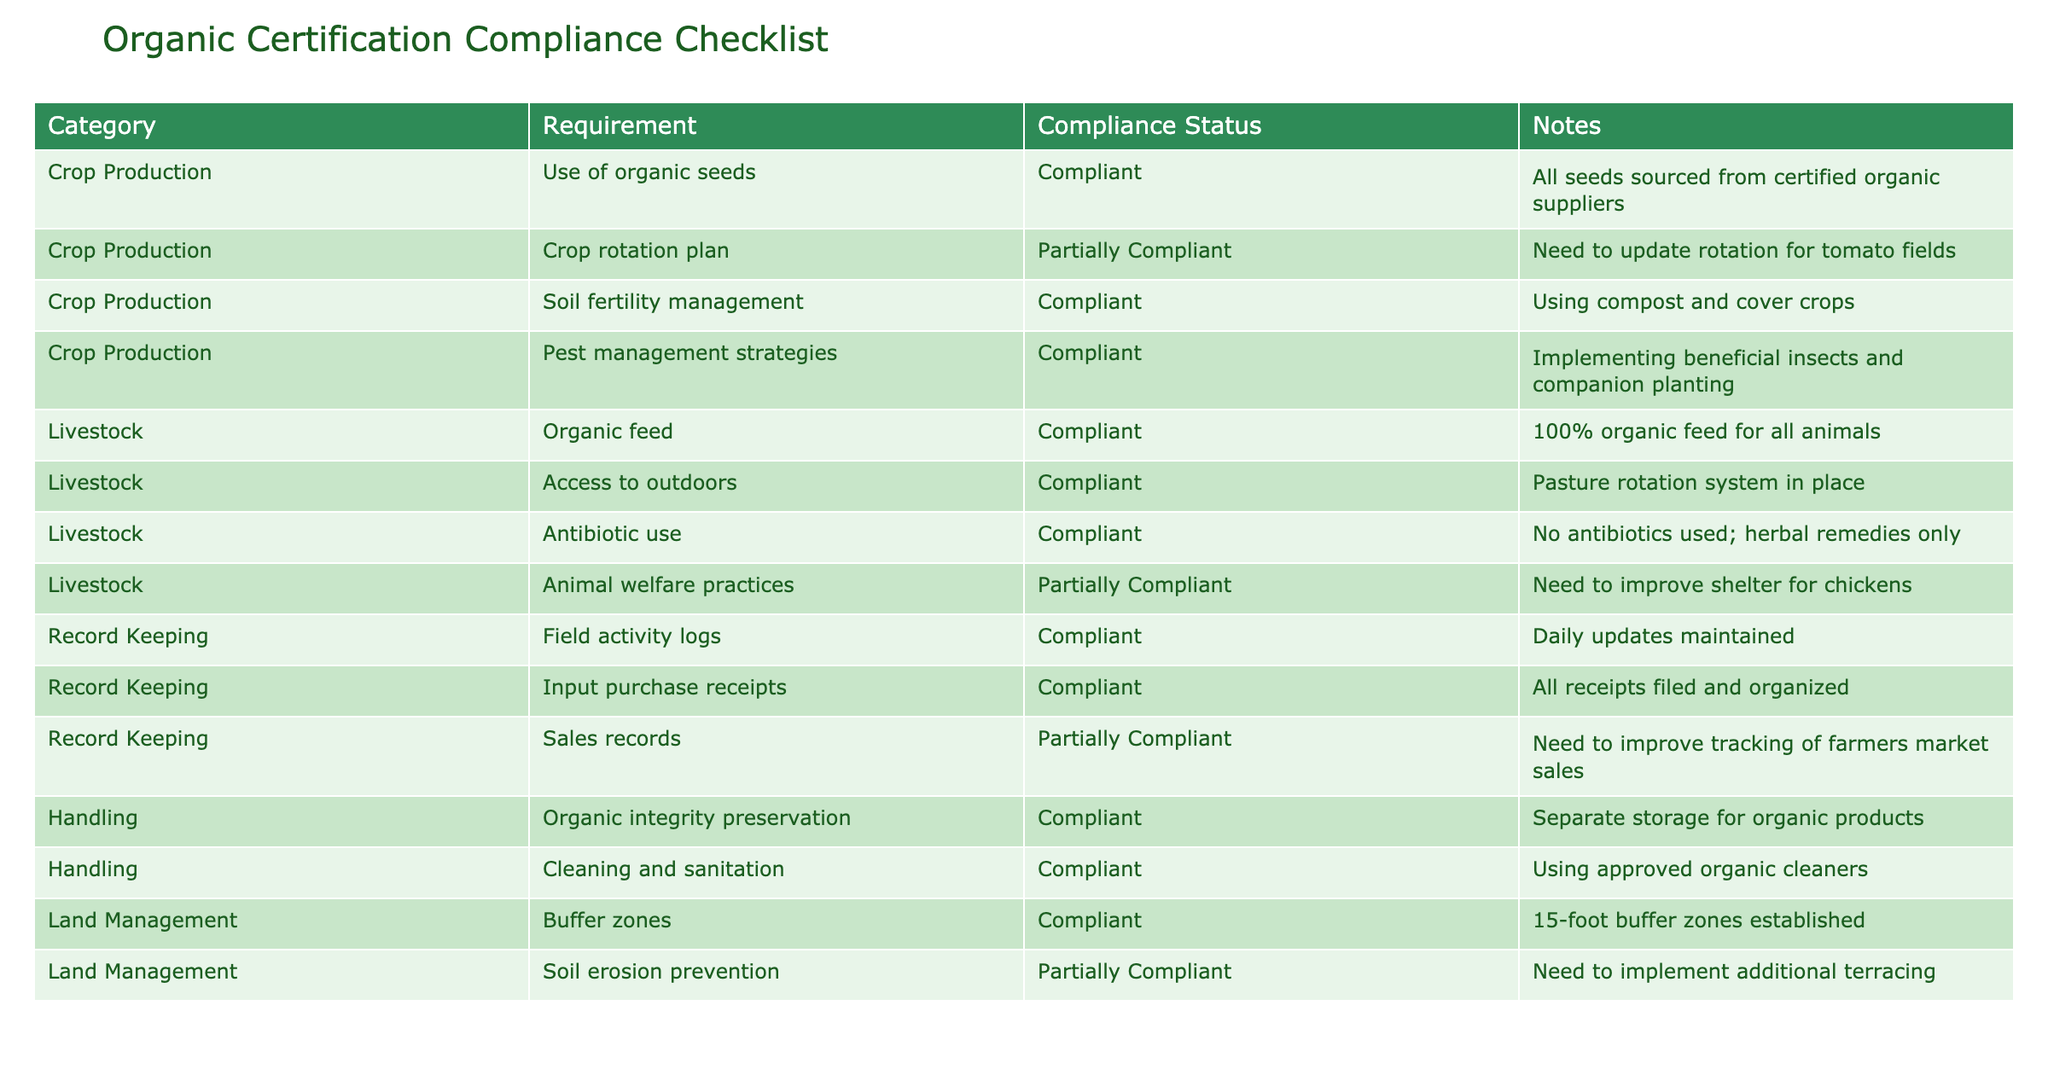What is the compliance status for the use of organic seeds? The compliance status for the use of organic seeds is "Compliant," as stated directly in the table under the Crop Production category.
Answer: Compliant How many requirements are listed under Livestock? There are four requirements listed under the Livestock category: organic feed, access to outdoors, antibiotic use, and animal welfare practices.
Answer: Four What percentage of the requirements are compliant in the Crop Production category? There are four requirements in the Crop Production category, out of which three are compliant. Therefore, the percentage is (3/4) * 100 = 75%.
Answer: 75% Are there any requirements in the Record Keeping category that are not fully compliant? Yes, there are two requirements in the Record Keeping category that are not fully compliant: the crop activity logs are compliant, but the sales records are only partially compliant.
Answer: Yes Which categories have requirements listed as "Partially Compliant"? The categories with requirements listed as "Partially Compliant" are Crop Production and Livestock. Specifically, in Crop Production, the crop rotation plan is partially compliant, and in Livestock, animal welfare practices are partially compliant.
Answer: Crop Production, Livestock What is the total number of requirements listed across all categories? The total number of requirements listed is calculated as follows: 4 (Crop Production) + 4 (Livestock) + 3 (Record Keeping) + 2 (Handling) + 2 (Land Management) = 15 requirements.
Answer: 15 In which area is the application of organic integrity preservation compliant? The area of handling includes the organic integrity preservation requirement, and it is compliant, with separate storage for organic products as noted in the table.
Answer: Handling What specific improvement is needed for the soil erosion prevention requirement? The table indicates that additional terracing needs to be implemented to improve soil erosion prevention in Land Management.
Answer: Additional terracing needed 